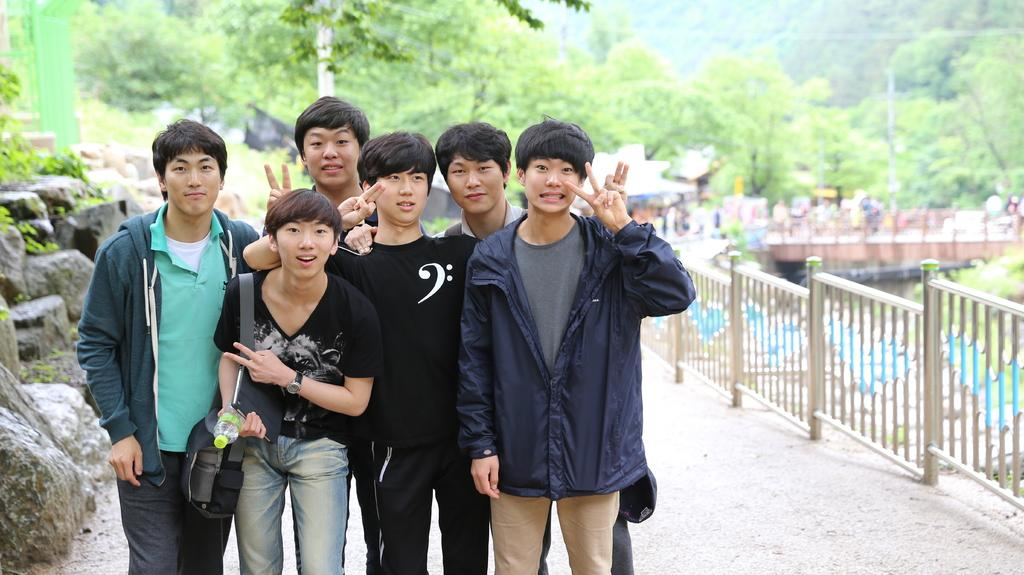How many people are in the group visible in the image? There is a group of people standing in the image, but the exact number cannot be determined from the provided facts. What is the purpose of the fence in the image? The purpose of the fence in the image cannot be determined from the provided facts. What is the water in the image used for? The purpose of the water in the image cannot be determined from the provided facts. How does the bridge connect the two sides in the image? The bridge connects the two sides in the image by spanning across the water. What type of rocks are present in the image? The type of rocks in the image cannot be determined from the provided facts. What kind of trees are in the image? The type of trees in the image cannot be determined from the provided facts. What is the building in the background of the image used for? The purpose of the building in the background of the image cannot be determined from the provided facts. Can you see any bees flying around the people in the image? There is no mention of bees in the provided facts, so it cannot be determined if any are present in the image. What is the source of the worm's anger in the image? There is no mention of a worm or any emotion in the provided facts, so it cannot be determined if any are present in the image. 